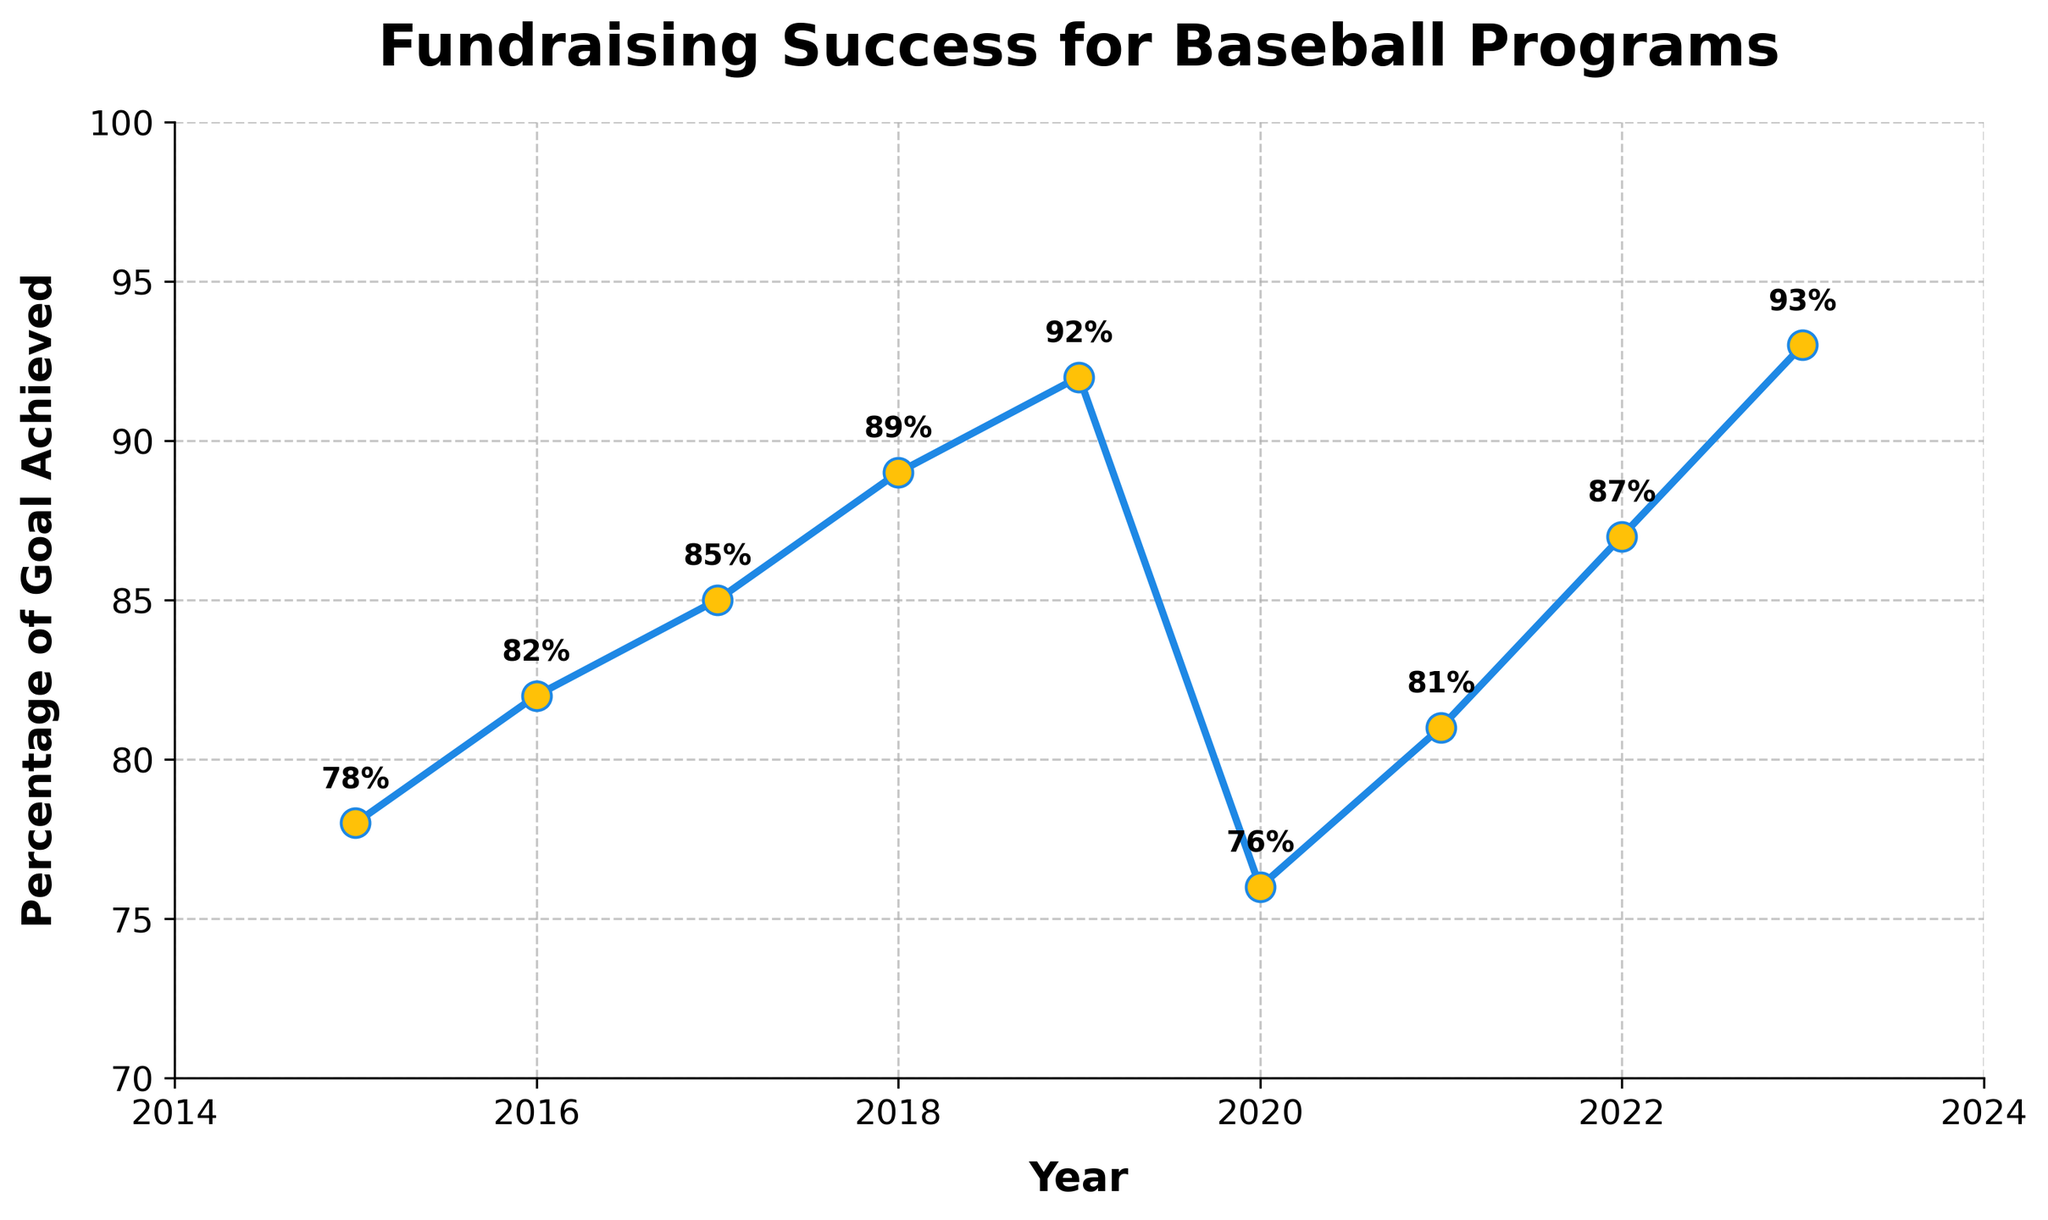Which year had the highest percentage of goal achieved? Check the peak point in the line chart and note the corresponding year on the x-axis. Specifically, the highest percentage is 93%, which occurs in 2023.
Answer: 2023 What is the difference in the percentage of goal achieved between 2020 and 2023? Identify the percentages for both years on the y-axis: 76% in 2020 and 93% in 2023. Calculate the difference: 93% - 76% = 17%.
Answer: 17% How did the percentage of goal achieved change from 2019 to 2020? Compare the two years by checking the y-axis values: 92% in 2019 and 76% in 2020, noting a decrease. The change is 92% - 76% = 16%.
Answer: Decreased by 16% Which year saw the sharpest increase in the percentage of goal achieved compared to the previous year? Calculate the year-over-year increases: 2015-2016 = 4%, 2016-2017 = 3%, 2017-2018 = 4%, 2018-2019 = 3%, 2019-2020 = -16%, 2020-2021 = 5%, 2021-2022 = 6%, and 2022-2023 = 6%. The sharpest increase of 6% occurs from 2021 to 2022 and from 2022 to 2023.
Answer: 2021-2022 (or 2022-2023) What was the average percentage of the goal achieved over the first three years (2015-2017)? Calculate the average of the percentages over these years: (78% + 82% + 85%) / 3. This gives (245%) / 3 = 81.67%.
Answer: 81.67% Does the percentage of goal achieved in 2020 match any other year's percentage? Scan the y-axis values on the line chart and compare 2020's value (76%) with other years'. No other year matches this value.
Answer: No What is the trend for the percentage of goal achieved from 2015 to 2019? Observe the line chart from 2015 to 2019, noting a continuous upward trend from 78% to 92%.
Answer: Increasing During which consecutive three years did the percentage of goal achieved increase the most? Identify all consecutive three-year periods: 2015-2017 = 78% to 85% (7%), 2016-2018 = 82% to 89% (7%), 2017-2019 = 85% to 92% (7%). All these three-year periods show a 7% increase.
Answer: 2015-2017 (or 2016-2018, or 2017-2019) Which year had a lower percentage of goal achieved than the previous year? Check for any decline in the line chart: it slopes downward from 2019 (92%) to 2020 (76%).
Answer: 2020 